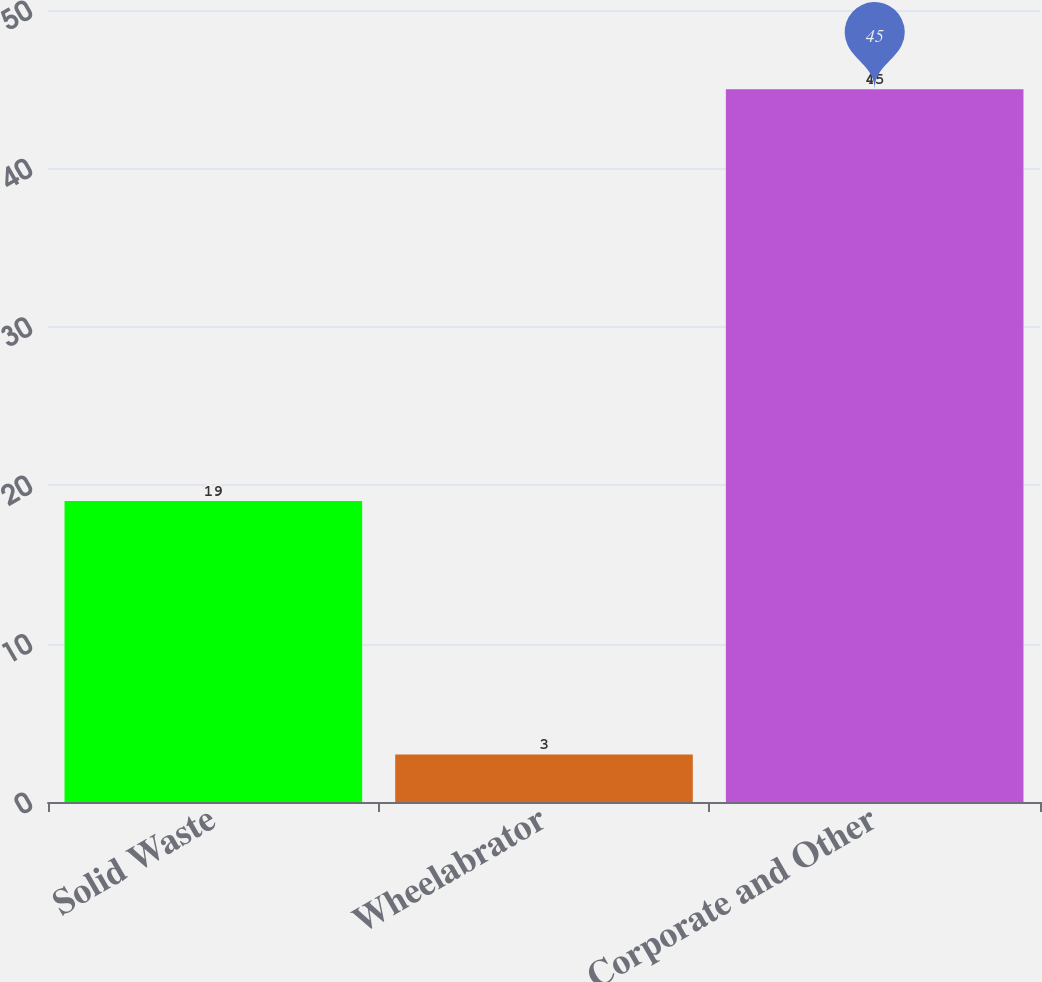Convert chart to OTSL. <chart><loc_0><loc_0><loc_500><loc_500><bar_chart><fcel>Solid Waste<fcel>Wheelabrator<fcel>Corporate and Other<nl><fcel>19<fcel>3<fcel>45<nl></chart> 